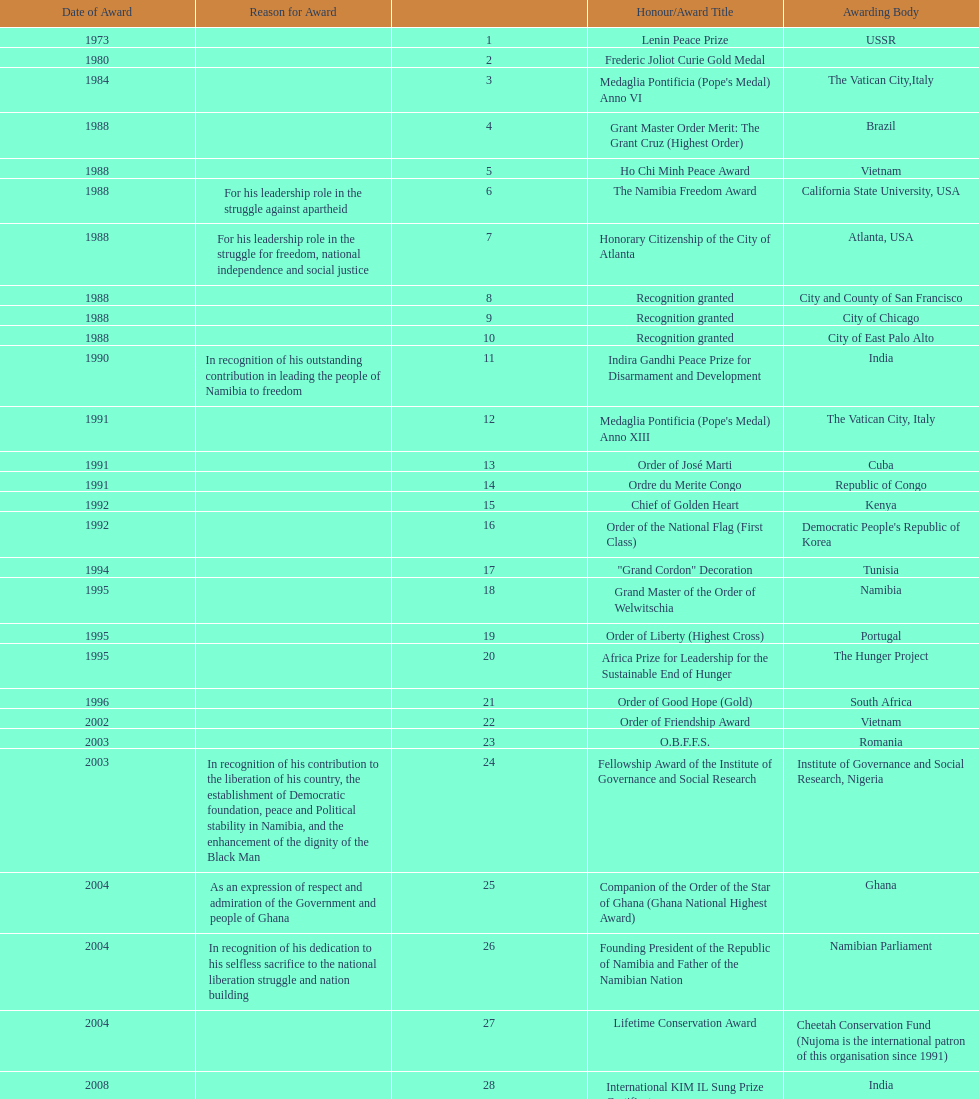What is the total number of awards that nujoma won? 29. 